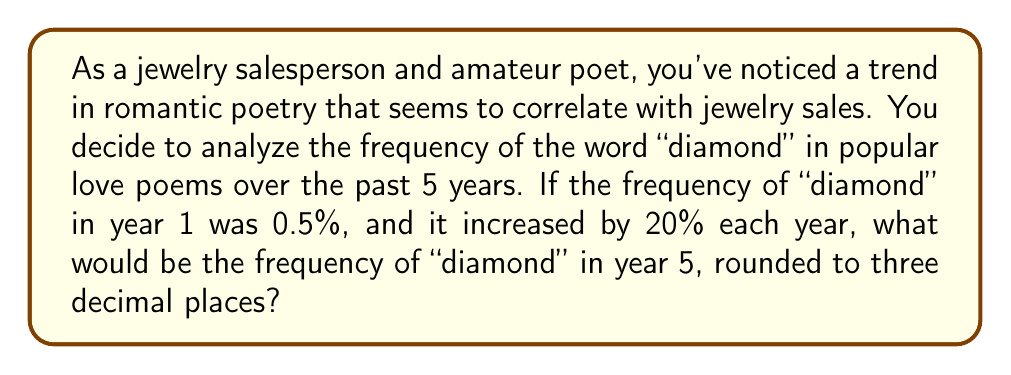Solve this math problem. Let's approach this step-by-step:

1) We start with an initial frequency of 0.5% in year 1.

2) The frequency increases by 20% each year. This means we multiply the previous year's frequency by 1.2 (100% + 20% = 120% = 1.2) for each subsequent year.

3) Let's calculate the frequency for each year:

   Year 1: 0.5%
   Year 2: $0.5\% \times 1.2 = 0.6\%$
   Year 3: $0.6\% \times 1.2 = 0.72\%$
   Year 4: $0.72\% \times 1.2 = 0.864\%$
   Year 5: $0.864\% \times 1.2 = 1.0368\%$

4) We can also express this as a single calculation:

   $$0.5\% \times (1.2)^4 = 0.5\% \times 2.0736 = 1.0368\%$$

5) Rounding to three decimal places:

   1.0368% ≈ 1.037%
Answer: 1.037% 